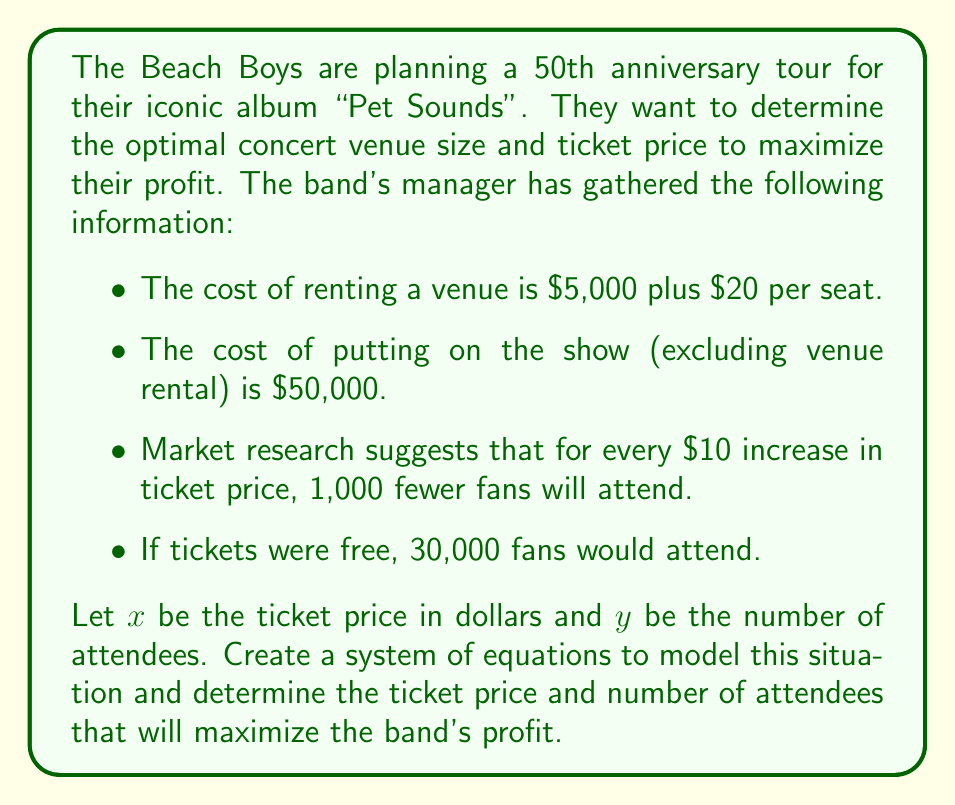Teach me how to tackle this problem. Let's approach this step-by-step:

1) First, we need to express $y$ (number of attendees) in terms of $x$ (ticket price):
   $$y = 30000 - 100x$$
   (For every $\$10$ increase, 1000 fewer attend, so for every $\$1$ increase, 100 fewer attend)

2) Now, let's create an expression for the total revenue:
   Revenue = Ticket price × Number of attendees
   $$R = xy = x(30000 - 100x) = 30000x - 100x^2$$

3) Next, let's create an expression for the total cost:
   Cost = Venue rental + Show cost
   $$C = (5000 + 20y) + 50000 = 55000 + 20y$$
   Substituting $y$ with the expression from step 1:
   $$C = 55000 + 20(30000 - 100x) = 655000 - 2000x$$

4) The profit (P) is the difference between revenue and cost:
   $$P = R - C = (30000x - 100x^2) - (655000 - 2000x)$$
   $$P = 32000x - 100x^2 - 655000$$

5) To maximize profit, we need to find the vertex of this quadratic function. The x-coordinate of the vertex will give us the optimal ticket price. We can find this by setting the derivative of P equal to zero:

   $$\frac{dP}{dx} = 32000 - 200x$$
   $$0 = 32000 - 200x$$
   $$200x = 32000$$
   $$x = 160$$

6) Now that we know the optimal ticket price ($\$160$), we can find the number of attendees:
   $$y = 30000 - 100(160) = 14000$$

7) To verify this is a maximum (not minimum), we can check that the second derivative is negative:
   $$\frac{d^2P}{dx^2} = -200$$ (which is indeed negative)

8) Finally, we can calculate the maximum profit:
   $$P = 32000(160) - 100(160)^2 - 655000 = 929000$$
Answer: The optimal ticket price is $\$160$, and the optimal number of attendees is 14,000. This will result in a maximum profit of $\$929,000$. 